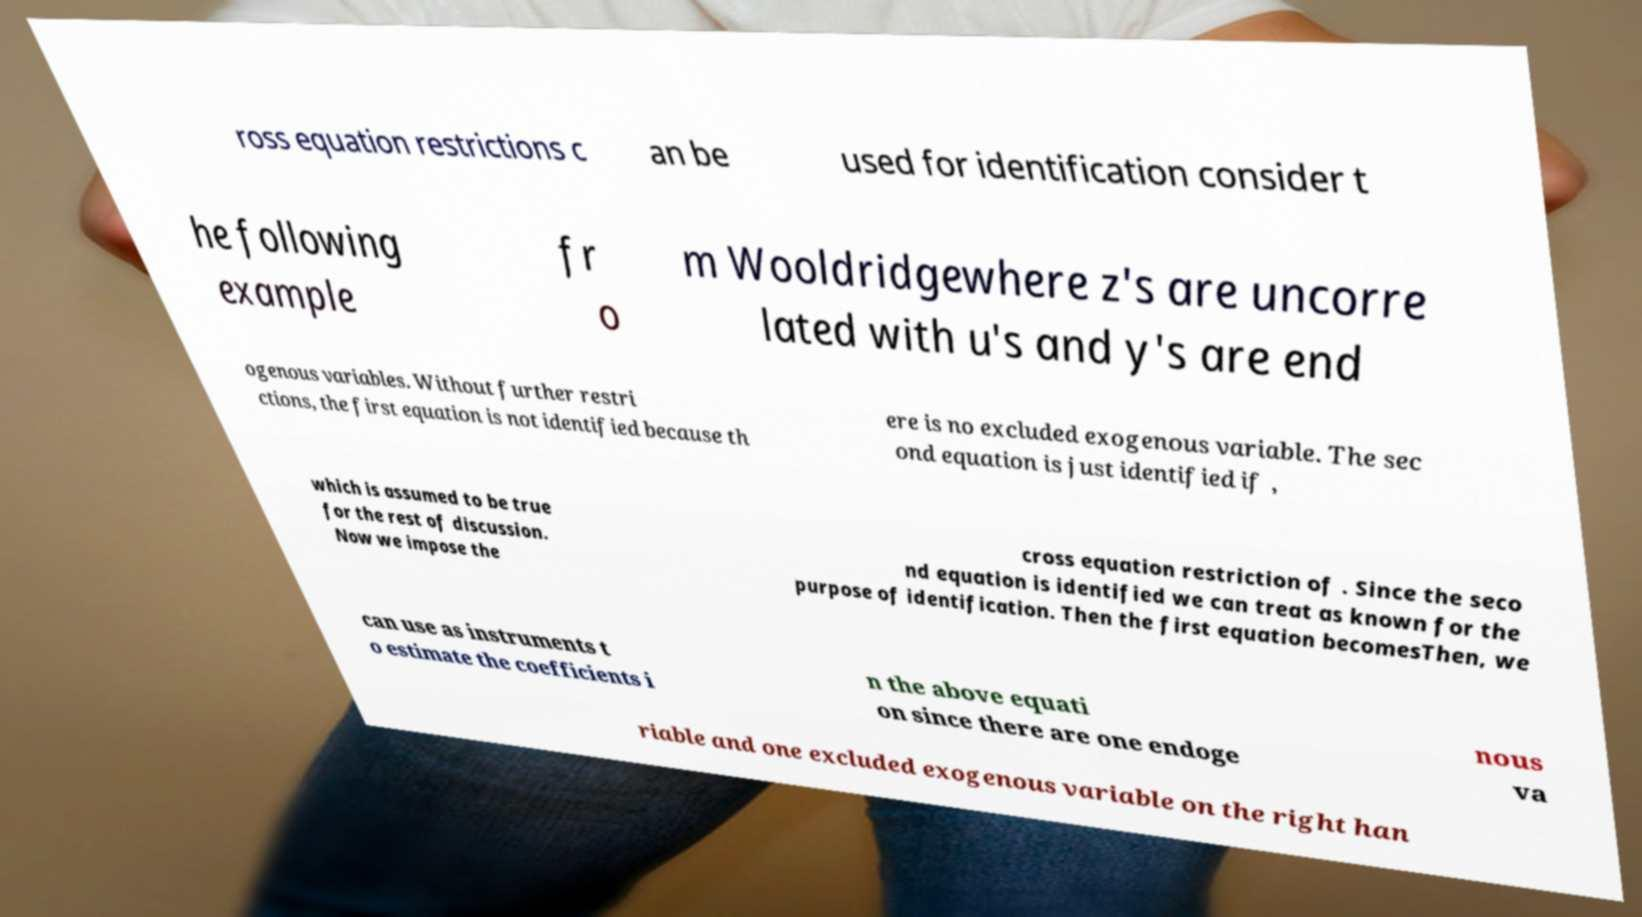What messages or text are displayed in this image? I need them in a readable, typed format. ross equation restrictions c an be used for identification consider t he following example fr o m Wooldridgewhere z's are uncorre lated with u's and y's are end ogenous variables. Without further restri ctions, the first equation is not identified because th ere is no excluded exogenous variable. The sec ond equation is just identified if , which is assumed to be true for the rest of discussion. Now we impose the cross equation restriction of . Since the seco nd equation is identified we can treat as known for the purpose of identification. Then the first equation becomesThen, we can use as instruments t o estimate the coefficients i n the above equati on since there are one endoge nous va riable and one excluded exogenous variable on the right han 